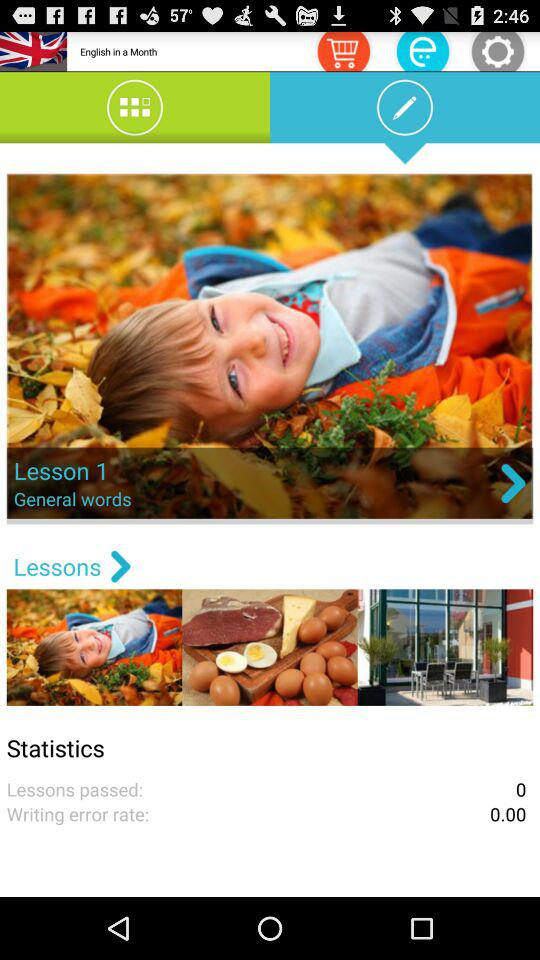How many lessons have been passed?
Answer the question using a single word or phrase. 0 